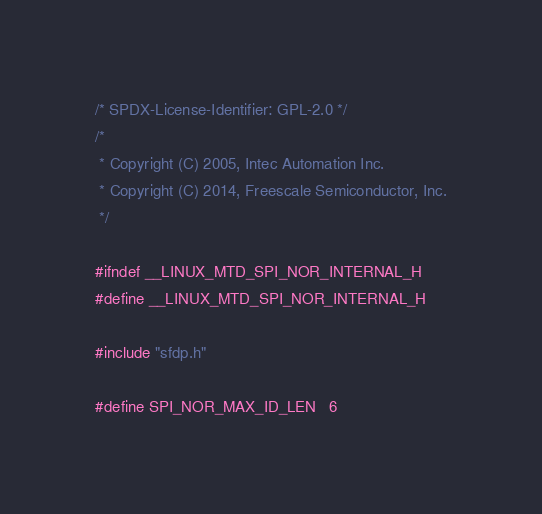Convert code to text. <code><loc_0><loc_0><loc_500><loc_500><_C_>/* SPDX-License-Identifier: GPL-2.0 */
/*
 * Copyright (C) 2005, Intec Automation Inc.
 * Copyright (C) 2014, Freescale Semiconductor, Inc.
 */

#ifndef __LINUX_MTD_SPI_NOR_INTERNAL_H
#define __LINUX_MTD_SPI_NOR_INTERNAL_H

#include "sfdp.h"

#define SPI_NOR_MAX_ID_LEN	6
</code> 